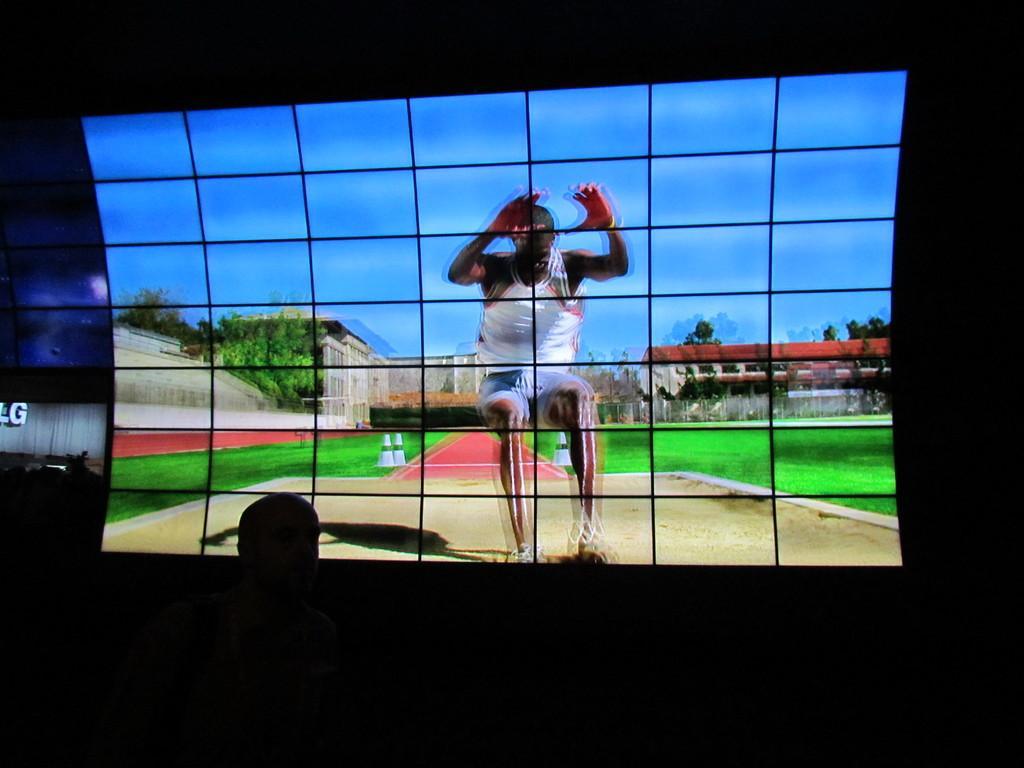In one or two sentences, can you explain what this image depicts? In this picture I can observe a screen. In the screen there is a person standing on the ground. In the background there are some buildings, trees and a sky. In front of the screen there is a person. 